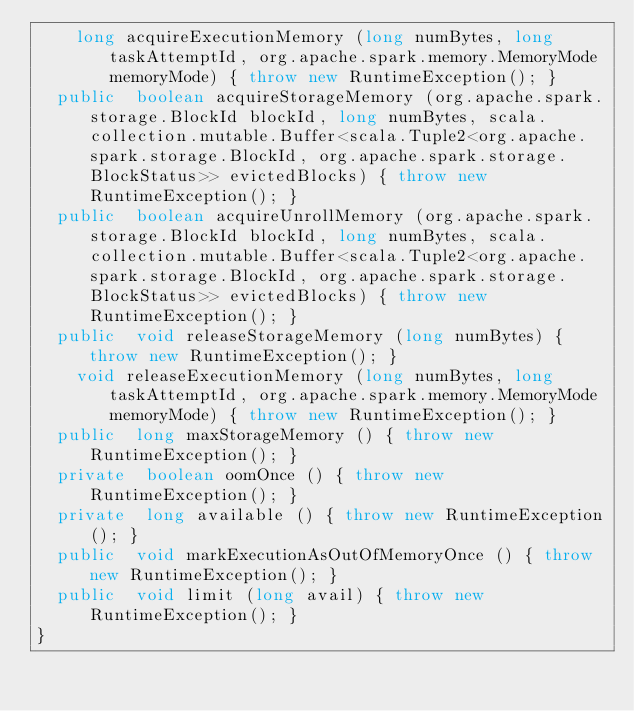Convert code to text. <code><loc_0><loc_0><loc_500><loc_500><_Java_>    long acquireExecutionMemory (long numBytes, long taskAttemptId, org.apache.spark.memory.MemoryMode memoryMode) { throw new RuntimeException(); }
  public  boolean acquireStorageMemory (org.apache.spark.storage.BlockId blockId, long numBytes, scala.collection.mutable.Buffer<scala.Tuple2<org.apache.spark.storage.BlockId, org.apache.spark.storage.BlockStatus>> evictedBlocks) { throw new RuntimeException(); }
  public  boolean acquireUnrollMemory (org.apache.spark.storage.BlockId blockId, long numBytes, scala.collection.mutable.Buffer<scala.Tuple2<org.apache.spark.storage.BlockId, org.apache.spark.storage.BlockStatus>> evictedBlocks) { throw new RuntimeException(); }
  public  void releaseStorageMemory (long numBytes) { throw new RuntimeException(); }
    void releaseExecutionMemory (long numBytes, long taskAttemptId, org.apache.spark.memory.MemoryMode memoryMode) { throw new RuntimeException(); }
  public  long maxStorageMemory () { throw new RuntimeException(); }
  private  boolean oomOnce () { throw new RuntimeException(); }
  private  long available () { throw new RuntimeException(); }
  public  void markExecutionAsOutOfMemoryOnce () { throw new RuntimeException(); }
  public  void limit (long avail) { throw new RuntimeException(); }
}
</code> 